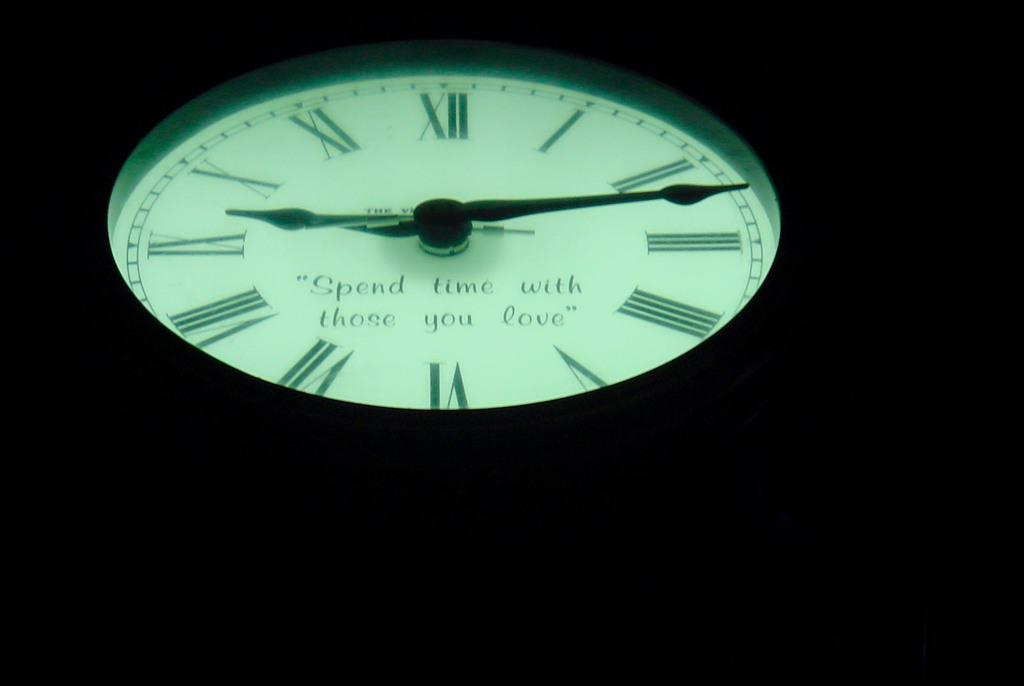Provide a one-sentence caption for the provided image. A glow in the dark clock face that says Spend time with those you love. 